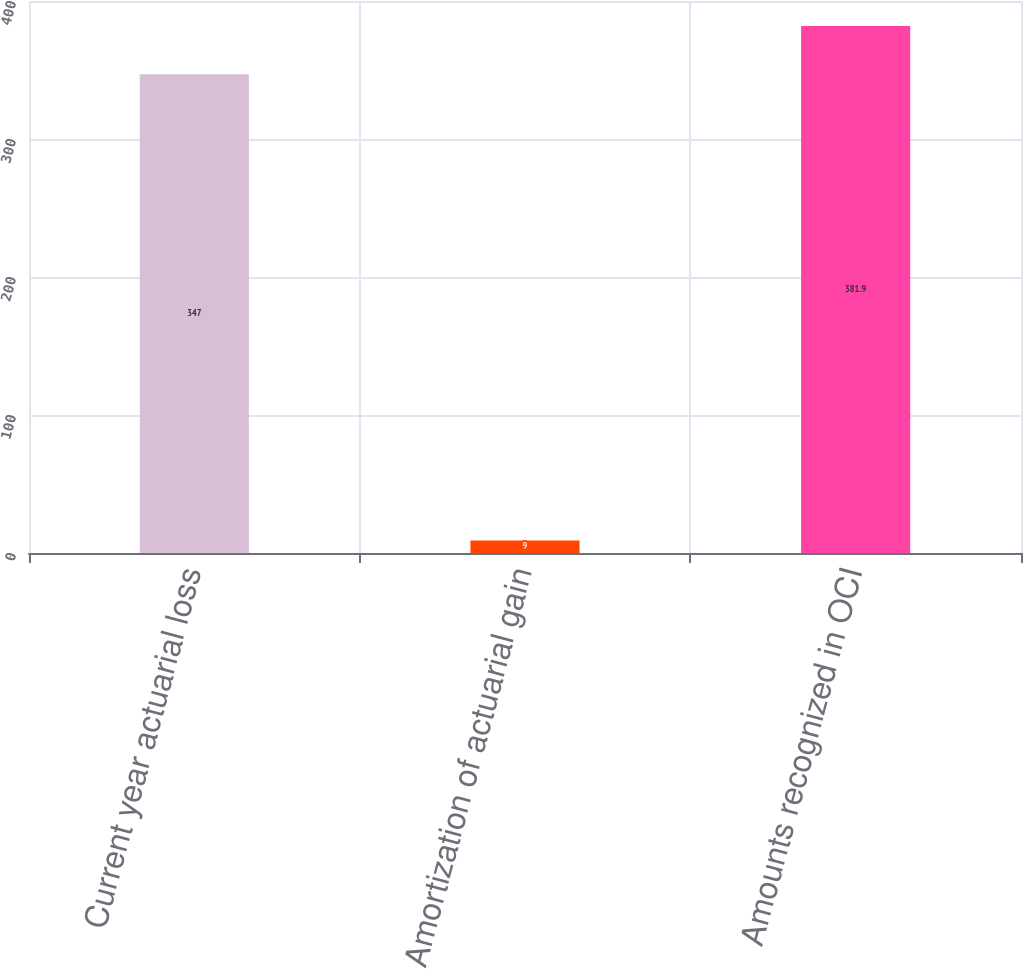<chart> <loc_0><loc_0><loc_500><loc_500><bar_chart><fcel>Current year actuarial loss<fcel>Amortization of actuarial gain<fcel>Amounts recognized in OCI<nl><fcel>347<fcel>9<fcel>381.9<nl></chart> 